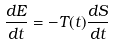<formula> <loc_0><loc_0><loc_500><loc_500>\frac { d E } { d t } = - T ( t ) \frac { d S } { d t }</formula> 